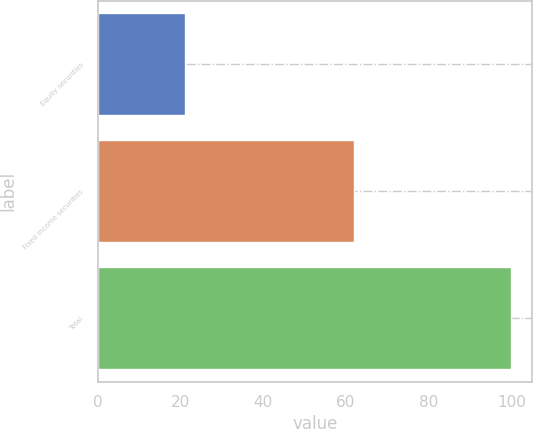<chart> <loc_0><loc_0><loc_500><loc_500><bar_chart><fcel>Equity securities<fcel>Fixed income securities<fcel>Total<nl><fcel>21<fcel>62<fcel>100<nl></chart> 